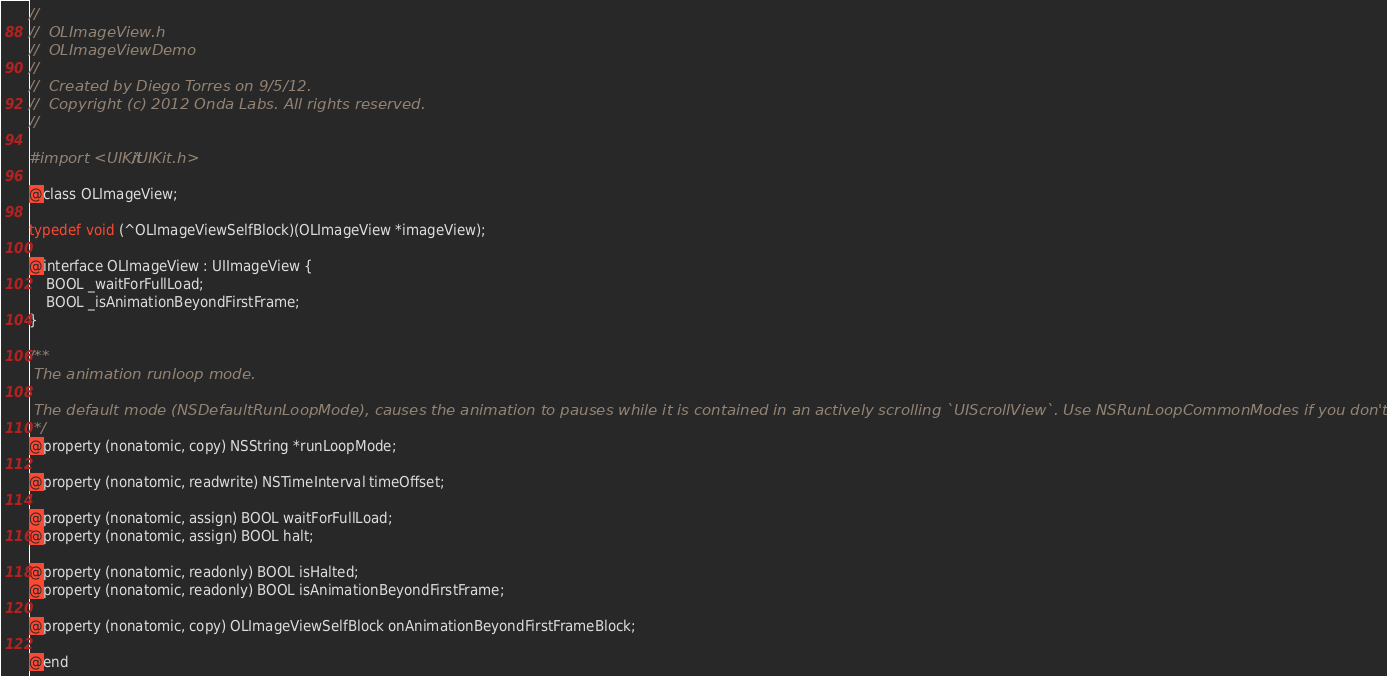<code> <loc_0><loc_0><loc_500><loc_500><_C_>//
//  OLImageView.h
//  OLImageViewDemo
//
//  Created by Diego Torres on 9/5/12.
//  Copyright (c) 2012 Onda Labs. All rights reserved.
//

#import <UIKit/UIKit.h>

@class OLImageView;

typedef void (^OLImageViewSelfBlock)(OLImageView *imageView);

@interface OLImageView : UIImageView {
    BOOL _waitForFullLoad;
    BOOL _isAnimationBeyondFirstFrame;
}

/**
 The animation runloop mode.
 
 The default mode (NSDefaultRunLoopMode), causes the animation to pauses while it is contained in an actively scrolling `UIScrollView`. Use NSRunLoopCommonModes if you don't want this behavior.
 */
@property (nonatomic, copy) NSString *runLoopMode;

@property (nonatomic, readwrite) NSTimeInterval timeOffset;

@property (nonatomic, assign) BOOL waitForFullLoad;
@property (nonatomic, assign) BOOL halt;

@property (nonatomic, readonly) BOOL isHalted;
@property (nonatomic, readonly) BOOL isAnimationBeyondFirstFrame;

@property (nonatomic, copy) OLImageViewSelfBlock onAnimationBeyondFirstFrameBlock;

@end
</code> 